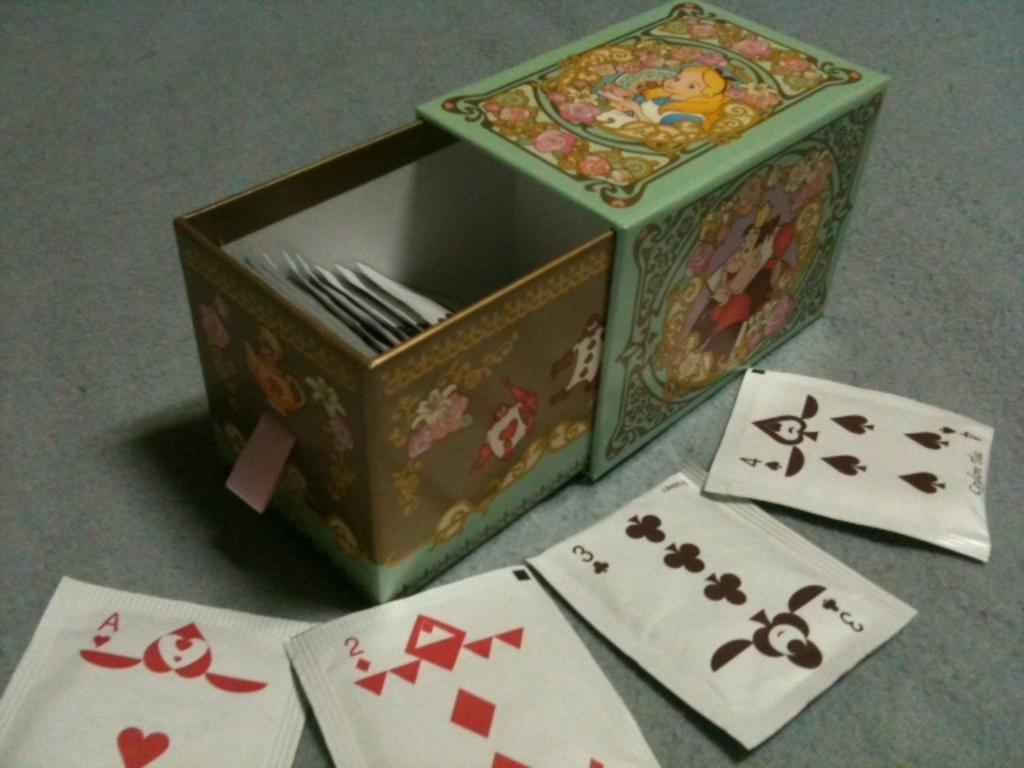What is the main object in the image? There is a box in the image. What can be observed on the surface of the box? The box has images on it. What is inside the box? There are items inside the box. What is located near the box? There are cards near the box. What type of drink is being poured from the box in the image? There is no drink being poured from the box in the image; it contains items, not a liquid. 